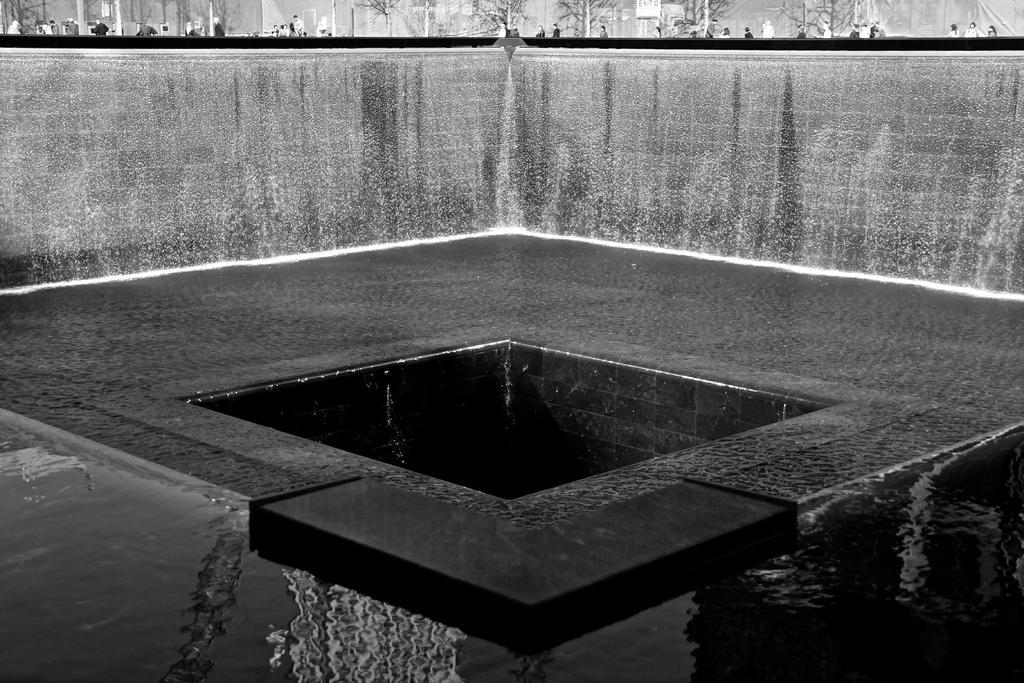In one or two sentences, can you explain what this image depicts? It is a black and white image and in this image we can see the fountain and also wall and trees and people. At the bottom we can see the water and also the ground. 